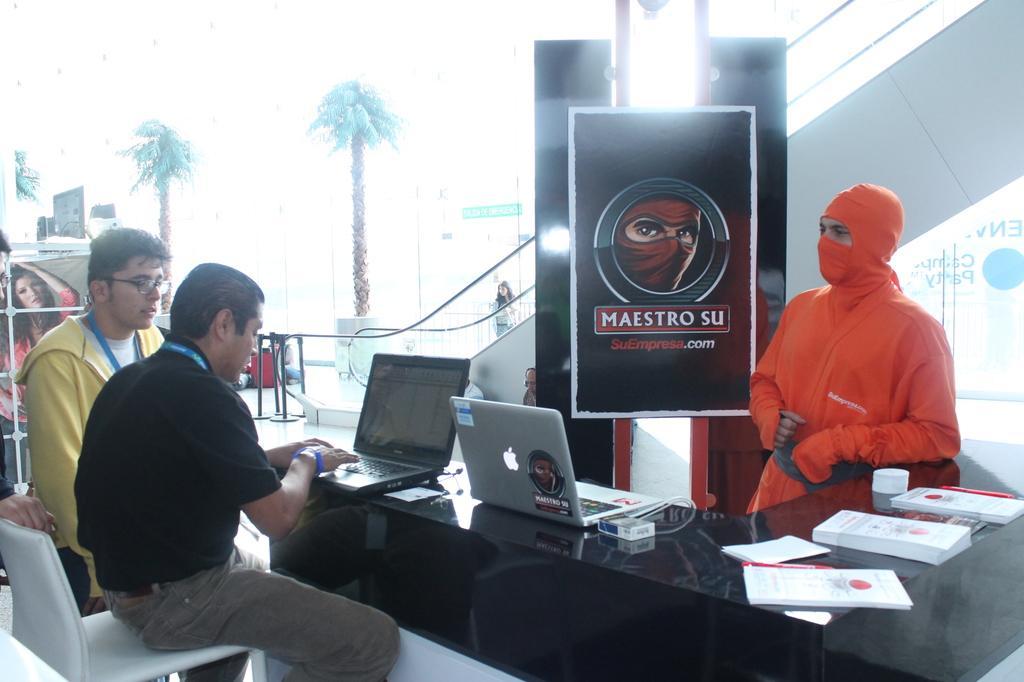Could you give a brief overview of what you see in this image? In this picture there is a man sitting on the chair and looking into the laptop. There are also other men who are standing. There is a poster. There are some trees and books on the table. 